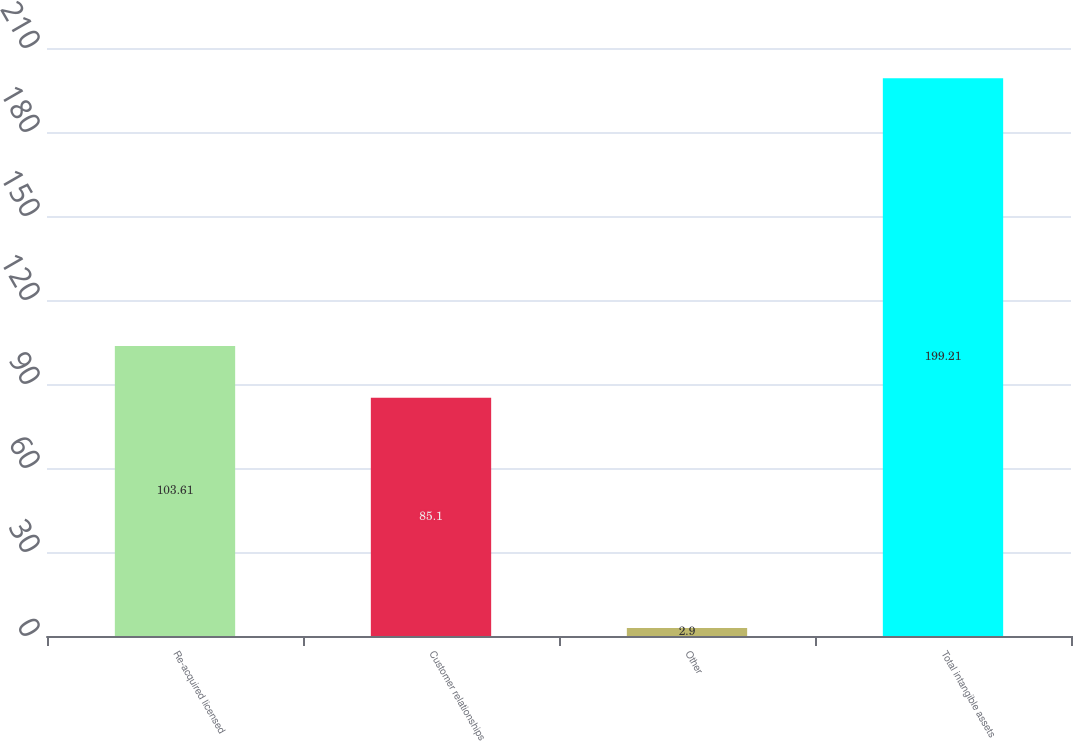Convert chart to OTSL. <chart><loc_0><loc_0><loc_500><loc_500><bar_chart><fcel>Re-acquired licensed<fcel>Customer relationships<fcel>Other<fcel>Total intangible assets<nl><fcel>103.61<fcel>85.1<fcel>2.9<fcel>199.21<nl></chart> 